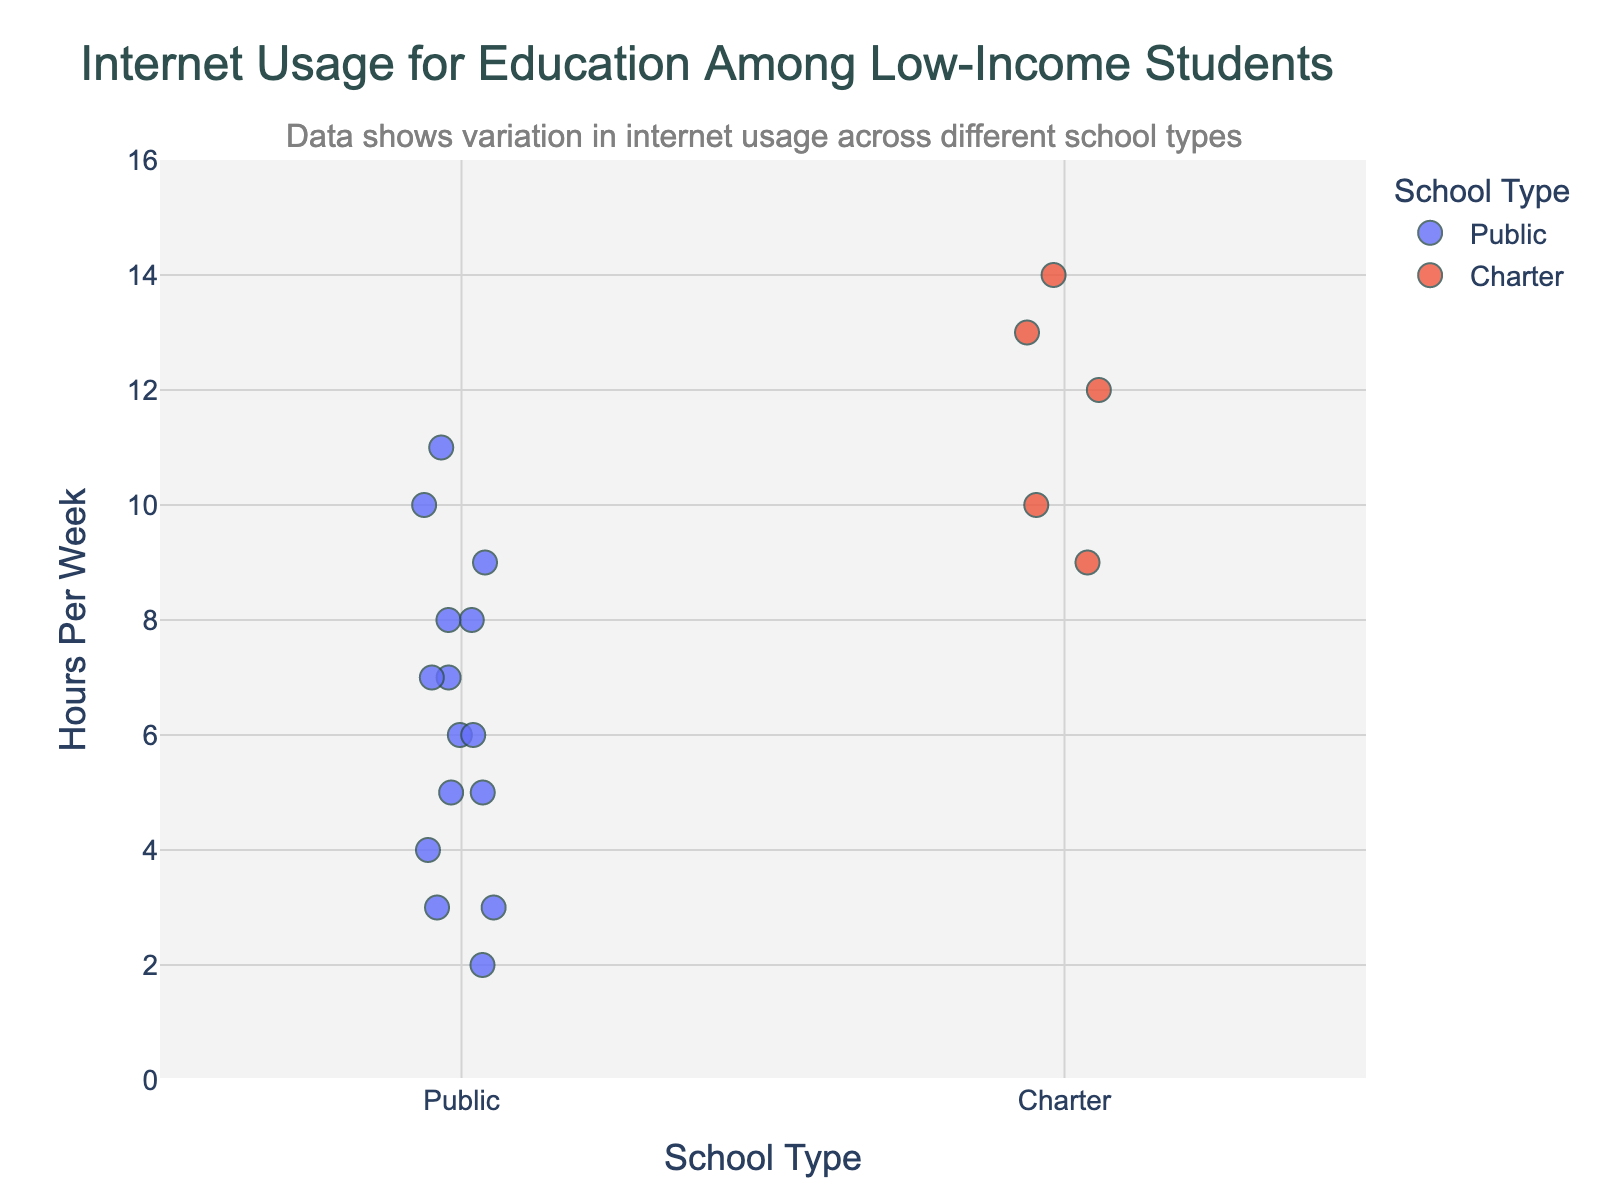What's the title of the plot? The title is located at the top of the plot and it indicates the main subject of the visualization. The title of the plot is "Internet Usage for Education Among Low-Income Students".
Answer: Internet Usage for Education Among Low-Income Students What does the y-axis represent? The y-axis is typically labeled on the left side of the plot and it describes what the vertical measurements correspond to. In this plot, the y-axis represents the "Hours Per Week" students use the internet for educational purposes.
Answer: Hours Per Week How many students attend charter schools compared to public schools? We need to count the number of data points (markers) for each school type on the x-axis. Charter schools have 5 data points (Aisha Patel, Keisha Brown, Sofia Martinez, Imani Washington, Zoe Chen) and public schools have 15 data points.
Answer: Charter: 5, Public: 15 Which student uses the internet the most for educational purposes? Identify the highest data point on the y-axis and look at the hover information to see the student's name. The highest point is at 14 hours per week, which corresponds to Zoe Chen from a charter school.
Answer: Zoe Chen Is there a noticeable difference in internet usage between public and charter school students? Compare the spread and central tendencies of the data points for each school type. Charter school students generally use more hours (ranging mainly from 8 to 14) while public school students have a broader spread but generally lower usage.
Answer: Charter school students use more hours on average What's the average internet usage for public school students? Sum the hours per week of all public school students and divide by the number of these students. (8+5+3+10+6+4+7+11+2+6+8+5+3+7+9=84, number of students=15, average=84/15).
Answer: 5.6 hours per week What is the range of hours spent using the internet for educational purposes among public school students? Identify the minimum and maximum values for public school students on the y-axis. The minimum is 2 hours (Rashid Ali) and the maximum is 11 hours (Tanisha Davis).
Answer: 2 to 11 hours Which school type has the student with the highest internet usage for educational purposes? Identify the highest data point on the y-axis, then check its corresponding school type. The highest data point (14 hours) belongs to a charter school student (Zoe Chen).
Answer: Charter school Are there any outliers in the public school data? Check for any isolated points significantly distant from the bulk of other points. The data points for Rashid Ali (2 hours) and Tanisha Davis (11 hours) can be considered outliers as they are on the extremes of the range.
Answer: Rashid Ali (2 hours), Tanisha Davis (11 hours) How does the median internet usage in charter schools compare to public schools? Find the middle value (median) of the sorted hours per week for each school type. Charter school data points: 8, 9, 10, 12, 13, median=10 hours. Public school data points: 2, 3, 3, 4, 5, 5, 6, 6, 7, 7, 8, 8, 9, 10, 11, median=6 hours.
Answer: Charter: 10 hours, Public: 6 hours 